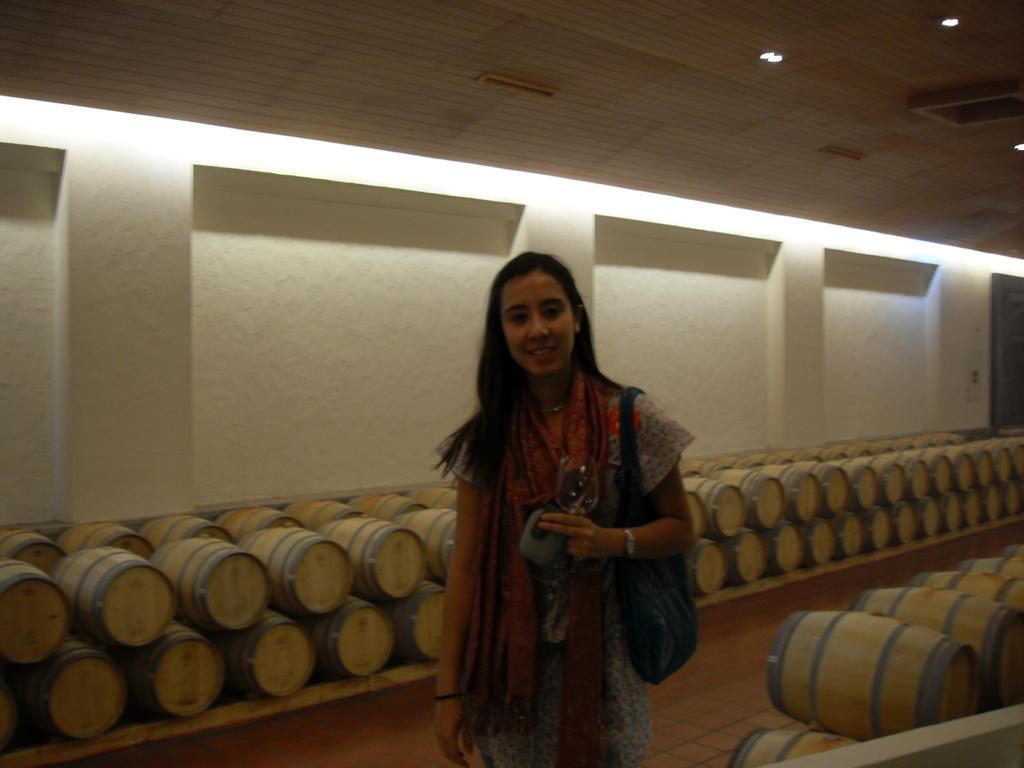Who is present in the image? There is a woman in the image. What is the woman doing in the image? The woman is standing and smiling. What is the woman holding or carrying in the image? The woman is carrying a bag. What can be seen in the background of the image? There are barrels in the background of the image. What is visible at the top of the image? There are lights at the top of the image. What songs is the woman singing in the image? There is no indication in the image that the woman is singing any songs. Can you see any pipes in the image? There is no pipe present in the image. 